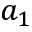<formula> <loc_0><loc_0><loc_500><loc_500>a _ { 1 }</formula> 